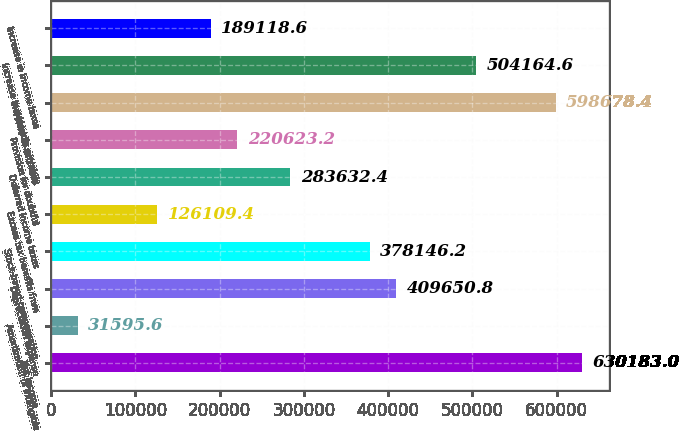Convert chart. <chart><loc_0><loc_0><loc_500><loc_500><bar_chart><fcel>Net income<fcel>Amortization of intangible<fcel>Depreciation expense<fcel>Stock-based compensation<fcel>Excess tax benefits from<fcel>Deferred income taxes<fcel>Provision for doubtful<fcel>Increase in accounts<fcel>Increase in accounts payable<fcel>Increase in income taxes<nl><fcel>630183<fcel>31595.6<fcel>409651<fcel>378146<fcel>126109<fcel>283632<fcel>220623<fcel>598678<fcel>504165<fcel>189119<nl></chart> 